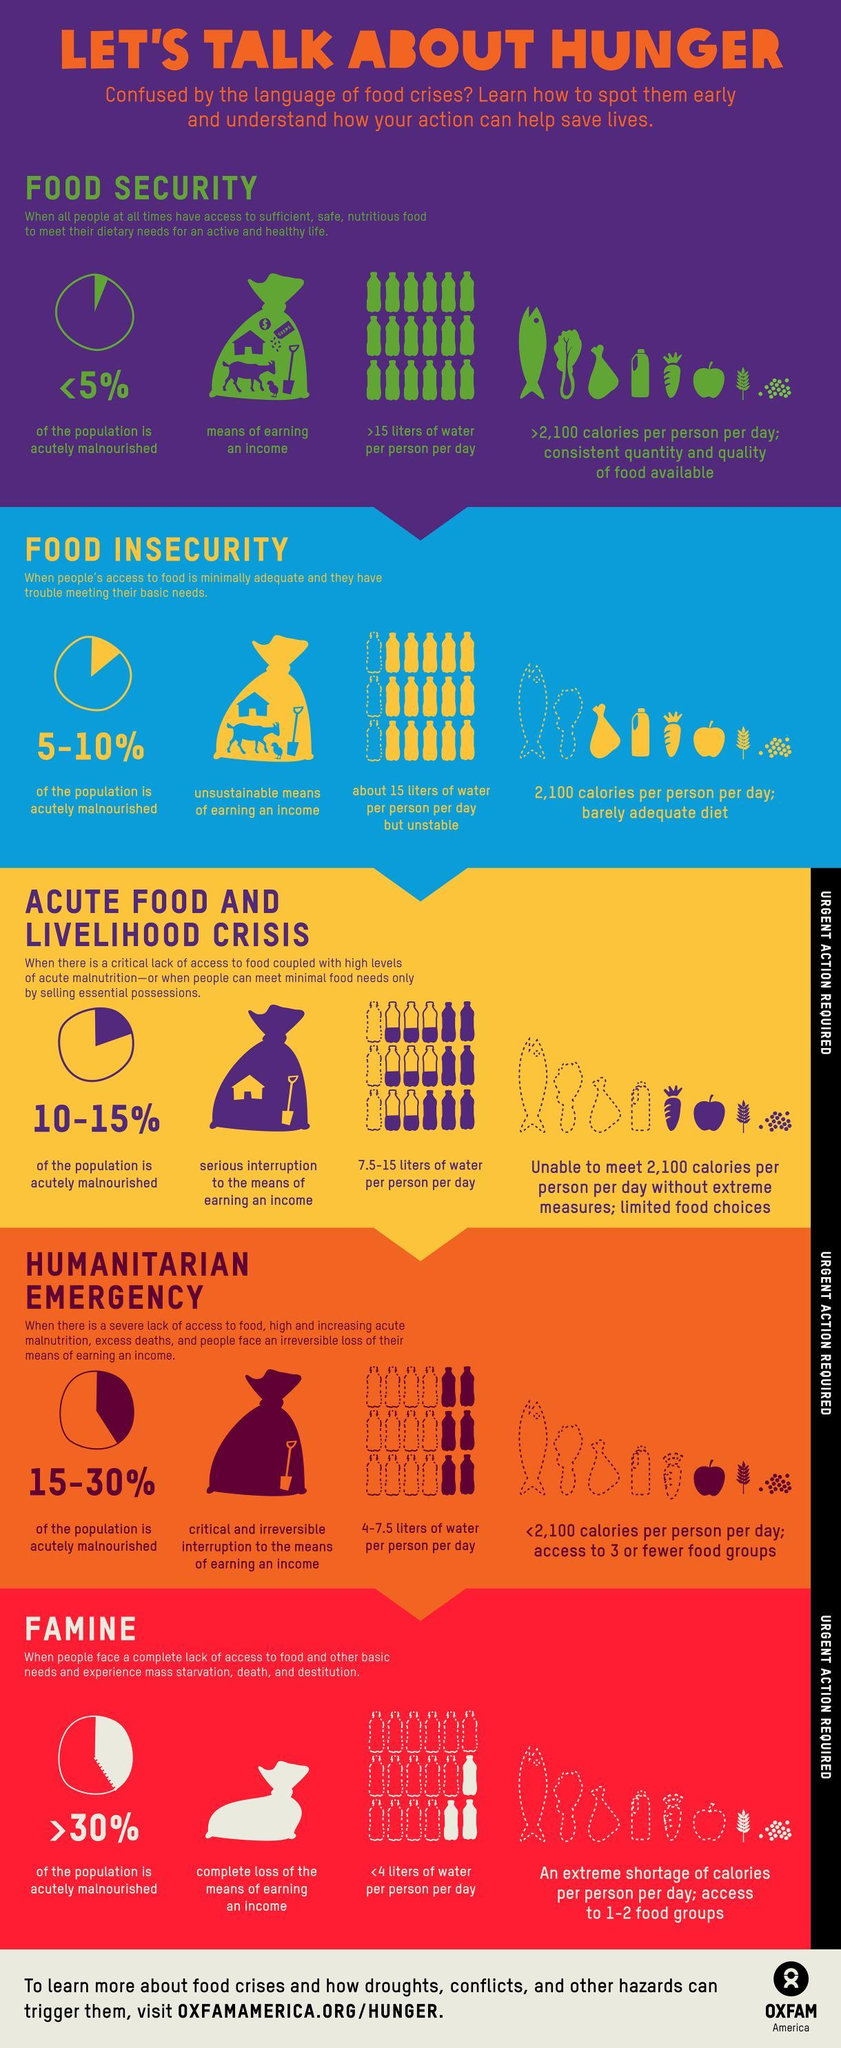During humanitarian emergency how many calories of food is available to a person per day?
Answer the question with a short phrase. <2,100 Which of these stages show 15 empty bottles and 3 full bottles? Famine From among the bags depicting the earnings, to which crisis stage does the empty bag belong? Famine What percentage of the population is acutely malnourished during Acute Food and livelihood crisis? 10 - 15% Which of the 3 food crisis stages, do not require 'Urgent action'? Food security, food insecurity Which of these stages show 12 empty bottles and 6 full bottles? Humanitarian Emergency During which of the food crisis stages, are more than 30% of the population acutely malnourished? Famine What percentage of the population is acutely malnourished when food insecurity prevails? 5 - 10% During which of these food crisis stages is the percentage of acutely malnourished 'population' the highest? Famine In which of these stages, is consistent quantity and quality of food available to the people? Food security During which of the stages do the people have no means of earning an income? Famine During which of the food crisis stages, is there a critical and irreversible interruption to the means of earning an income? Humanitarian Emergency During which of the stages do people have access to only 1-2 food groups? Famine How many litres of water are available during  Humanitarian emergencies (per person per day)? 4 - 7.5 liters How many food crises stages are mentioned? 5 Which of the three food crisis stages require "Urgent Action"? Acute food and livelihood crisis, Humanitarian emergency, Famine How many litres of water is available per person per day, during Acute food and livelihood crisis? 7.5 -15 In which of these stages, is a 'barely adequate diet' available to the people? Food insecurity How much water is available per person per day, during famine? <4 liters What percent of the population is accurately malnourished when food security prevails? <5% In which of these stages, are the people suffering from mass starvation, death and destitution? Famine 